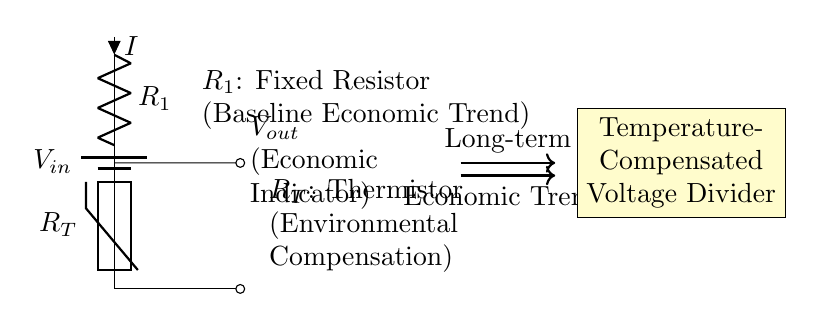What is the input voltage of the circuit? The circuit diagram indicates a symbol for a battery labeled as V in, representing the input voltage.
Answer: V in What component is used for environmental compensation? The component labeled as R T is a thermistor, which is specifically used for temperature compensation in the circuit.
Answer: Thermistor What is the role of the fixed resistor in this circuit? The fixed resistor labeled as R 1 serves as the baseline for the economic trend by setting a reference resistance for the voltage divider.
Answer: Baseline Economic Trend What type of circuit is illustrated here? The circuit is classified as a voltage divider, which splits the input voltage across the components in a way determined by their resistances.
Answer: Voltage Divider What indicates the output voltage in the circuit? The output voltage is indicated by the node marked as V out, where the voltage is taken from the point between R 1 and R T.
Answer: V out How does the circuit relate long-term economic trends to environmental factors? The circuit integrates a thermistor (R T), which adjusts the output voltage based on environmental temperature changes, thus reflecting economic indicators over time.
Answer: Environmental Compensation 